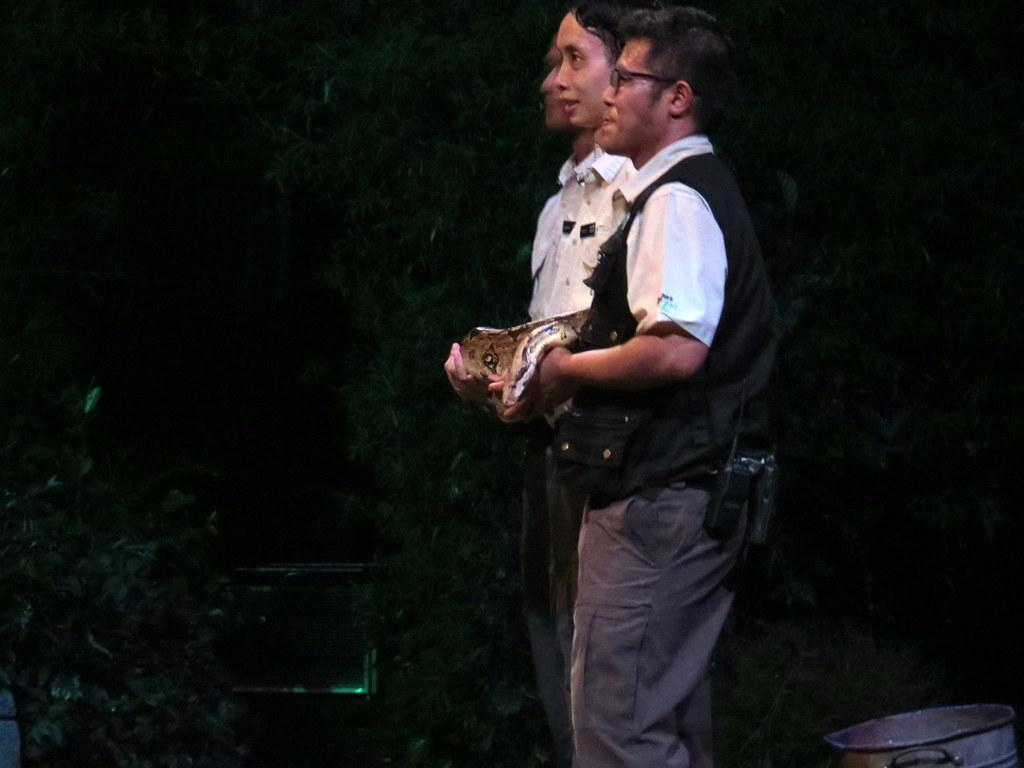Who or what can be seen in the image? There are people in the image. What are the people doing in the image? The people are standing. What are the people holding in their hands? The people are holding an object in their hands. What type of page can be seen in the image? There is no page present in the image. How many bulbs are visible in the image? There are no bulbs visible in the image. 